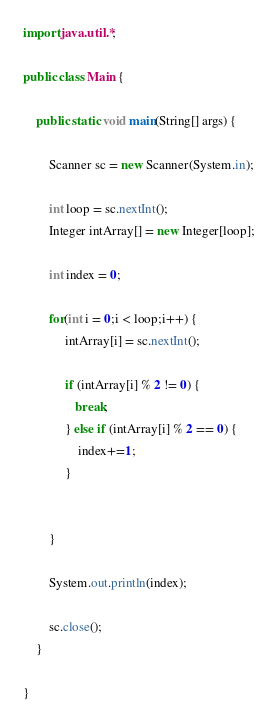<code> <loc_0><loc_0><loc_500><loc_500><_Java_>import java.util.*;

public class Main {

    public static void main(String[] args) {

        Scanner sc = new Scanner(System.in);
        
        int loop = sc.nextInt();
        Integer intArray[] = new Integer[loop];

        int index = 0;
        
        for(int i = 0;i < loop;i++) {
             intArray[i] = sc.nextInt();

             if (intArray[i] % 2 != 0) {
                break;
             } else if (intArray[i] % 2 == 0) {
                 index+=1;
             }

            
        }

        System.out.println(index);

        sc.close();
    }
    
}</code> 